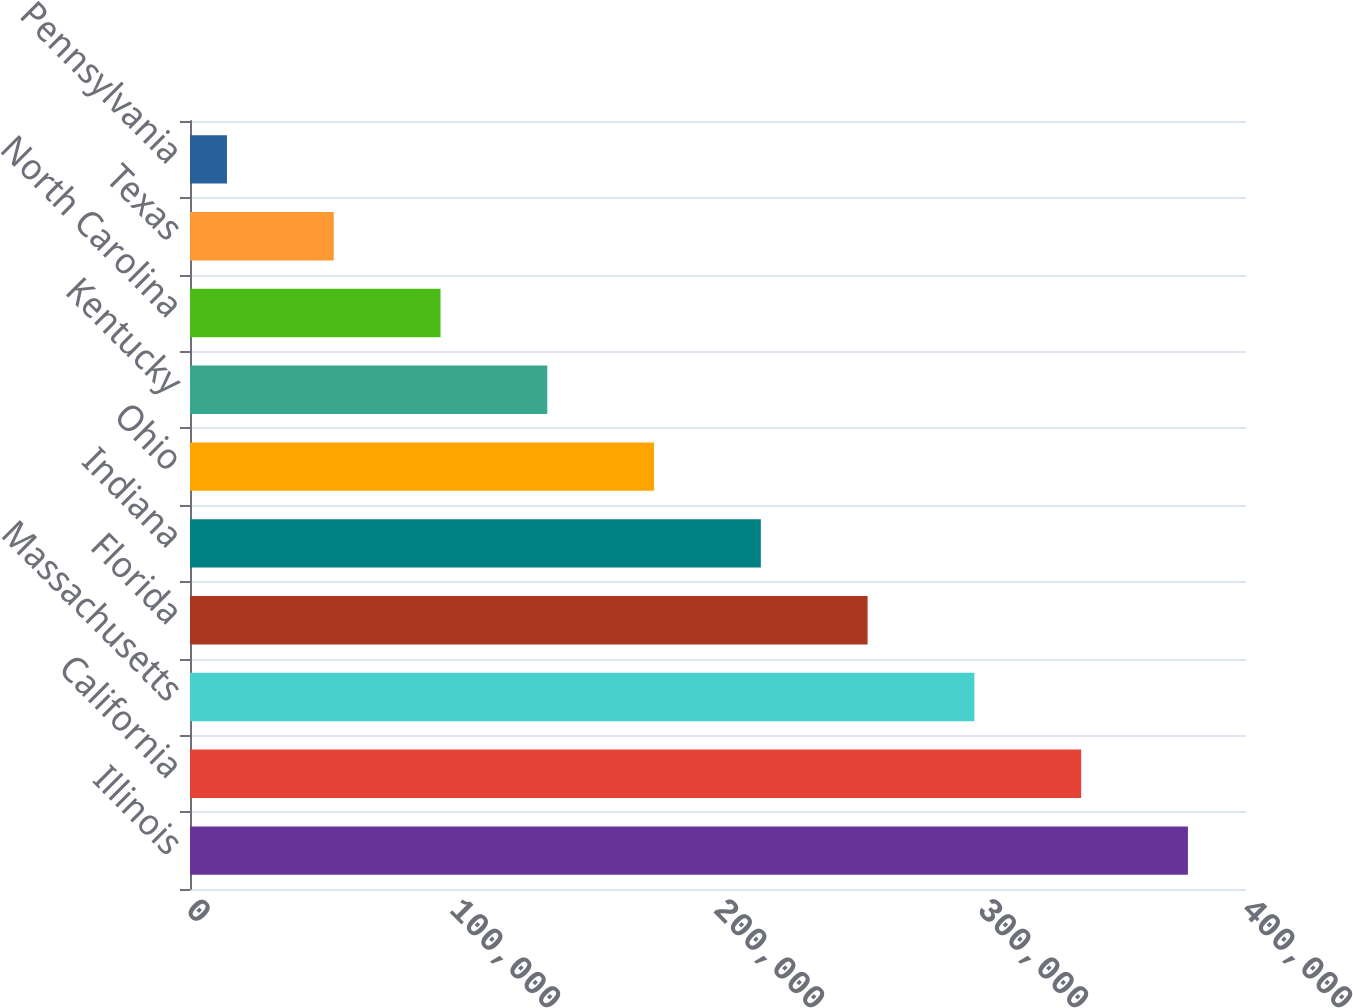Convert chart. <chart><loc_0><loc_0><loc_500><loc_500><bar_chart><fcel>Illinois<fcel>California<fcel>Massachusetts<fcel>Florida<fcel>Indiana<fcel>Ohio<fcel>Kentucky<fcel>North Carolina<fcel>Texas<fcel>Pennsylvania<nl><fcel>378004<fcel>337560<fcel>297115<fcel>256671<fcel>216226<fcel>175781<fcel>135337<fcel>94892.2<fcel>54447.6<fcel>14003<nl></chart> 